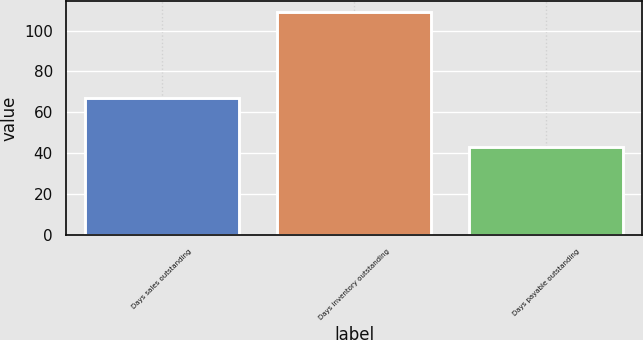Convert chart to OTSL. <chart><loc_0><loc_0><loc_500><loc_500><bar_chart><fcel>Days sales outstanding<fcel>Days inventory outstanding<fcel>Days payable outstanding<nl><fcel>67<fcel>109<fcel>43<nl></chart> 